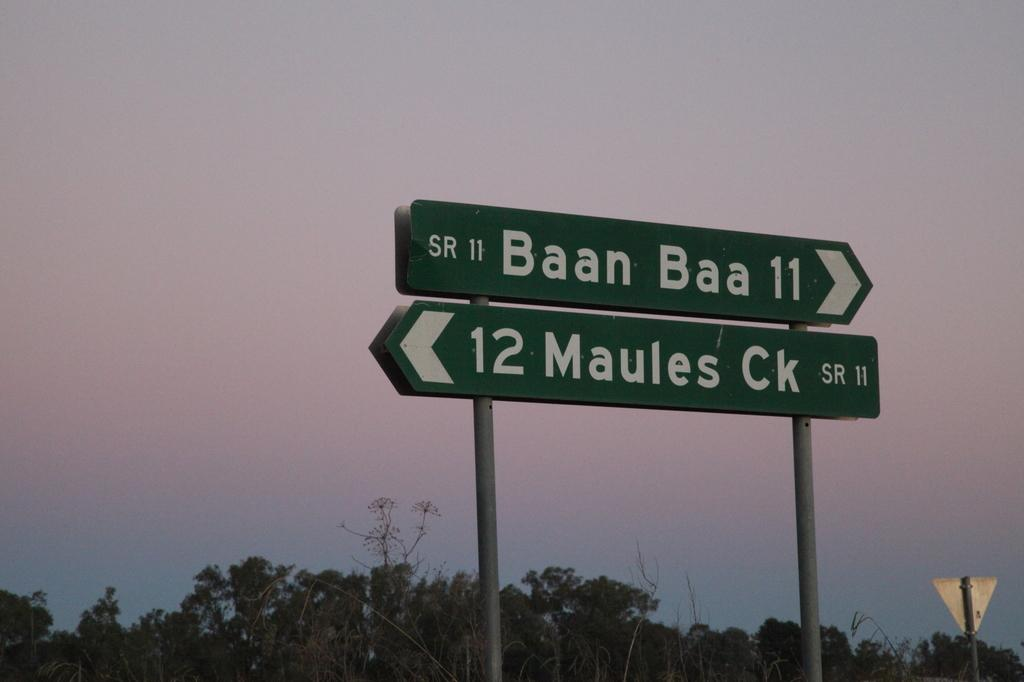<image>
Relay a brief, clear account of the picture shown. A freeway road destination sign that reads SR 11 BEAN BAA 11 12 MAUKES CK. 